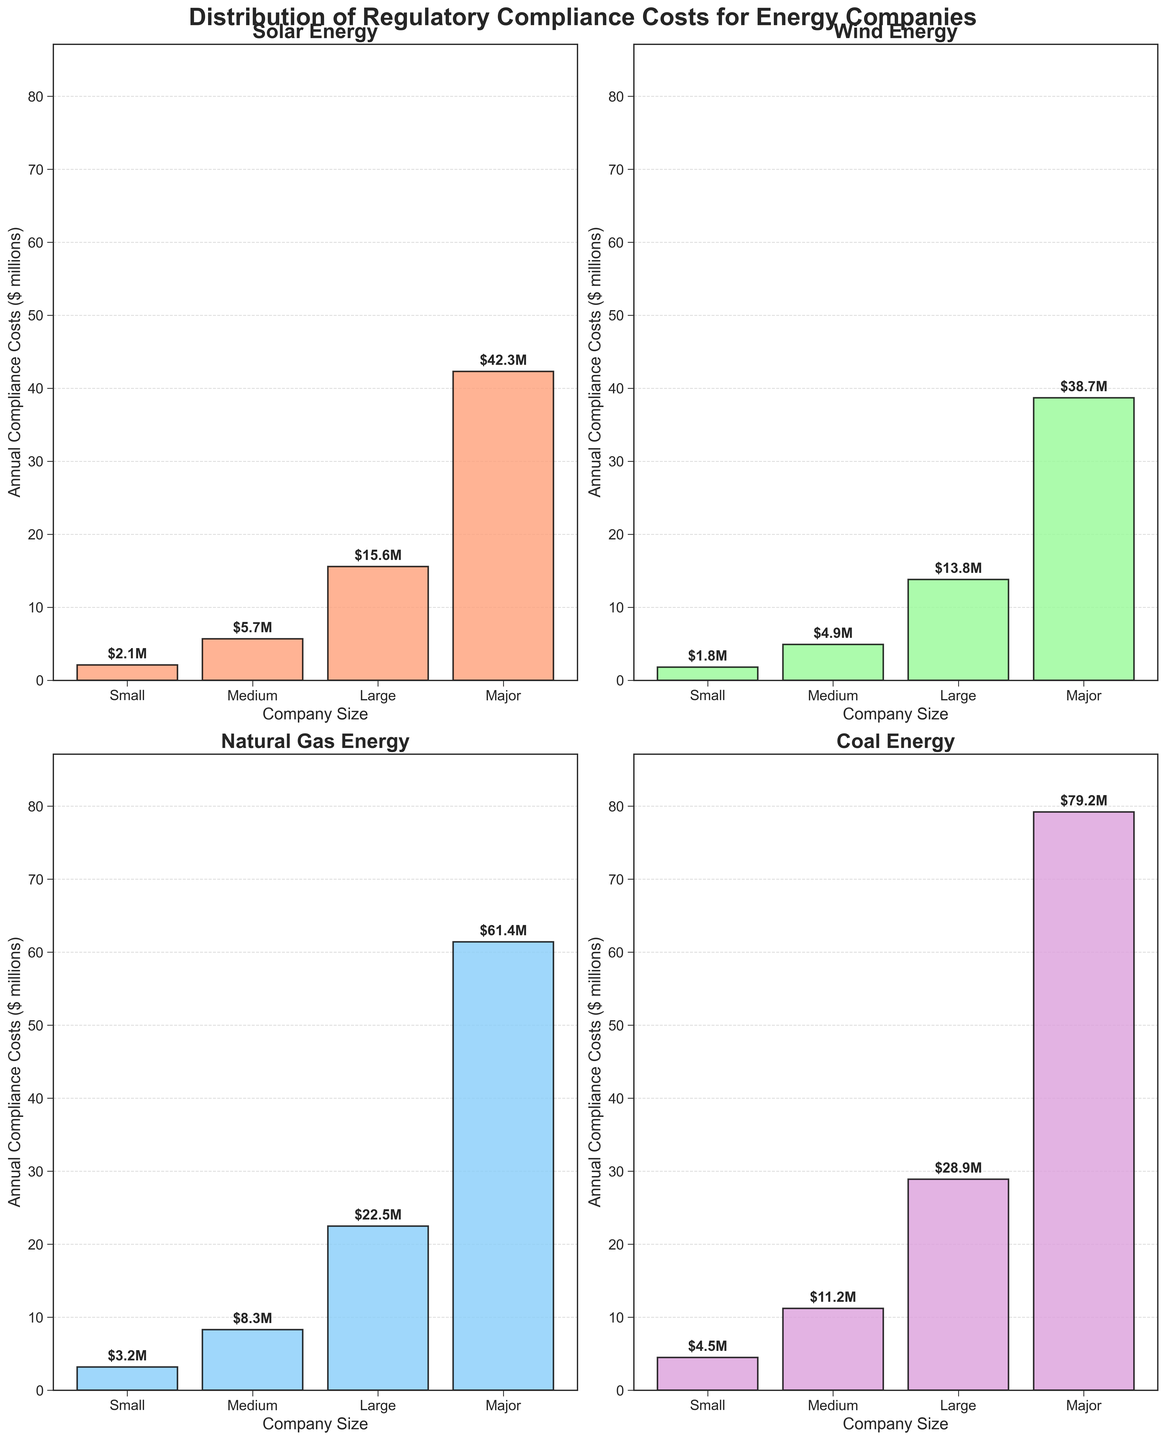What is the title of the figure? The title is located at the top of the figure and indicates the summary or main topic of the plots.
Answer: Distribution of Regulatory Compliance Costs for Energy Companies What are the four subsectors shown in the subplots? The subsectors are specified in the titles of each subplot and are labeled accordingly.
Answer: Solar, Wind, Natural Gas, Coal Which company size has the highest regulatory compliance costs in the Solar subsector? By inspecting the bar heights in the Solar subplot, the company size with the tallest bar represents the highest compliance costs.
Answer: Major What are the annual compliance costs for medium-sized Wind energy companies? Examine the bar corresponding to the Medium company size in the Wind subplot and read the value from the y-axis.
Answer: $4.9 million Which subsector has the lowest compliance cost for small companies? Compare the bars representing Small company sizes across all subsectors and identify the one with the smallest value.
Answer: Wind How do the compliance costs of Small Coal companies compare to that of Small Solar companies? Compare the heights of the bars for Small companies in the Coal and Solar subplots.
Answer: Small Coal companies have higher compliance costs than Small Solar companies What is the average compliance cost for medium-sized companies across all subsectors? Find the compliance costs for Medium companies in each subplot and calculate the average: (5.7 + 4.9 + 8.3 + 11.2) / 4.
Answer: $7.525 million What is the trend in compliance costs as company size increases in the Wind subsector? Observe how the height of the bars changes from Small to Major in the Wind subplot.
Answer: Compliance costs increase with company size Which subsector shows the largest increase in compliance costs from Medium to Large companies? Calculate the difference in compliance costs between Medium and Large company sizes for each subsector and identify the largest increase.
Answer: Natural Gas 